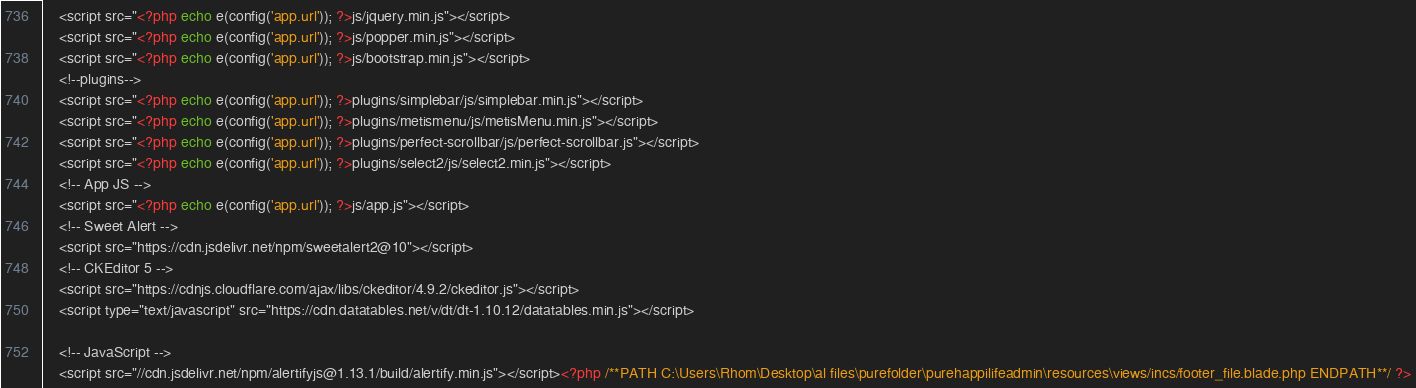<code> <loc_0><loc_0><loc_500><loc_500><_PHP_>
    <script src="<?php echo e(config('app.url')); ?>js/jquery.min.js"></script>
	<script src="<?php echo e(config('app.url')); ?>js/popper.min.js"></script>
	<script src="<?php echo e(config('app.url')); ?>js/bootstrap.min.js"></script>
	<!--plugins-->
	<script src="<?php echo e(config('app.url')); ?>plugins/simplebar/js/simplebar.min.js"></script>
	<script src="<?php echo e(config('app.url')); ?>plugins/metismenu/js/metisMenu.min.js"></script>
	<script src="<?php echo e(config('app.url')); ?>plugins/perfect-scrollbar/js/perfect-scrollbar.js"></script>
	<script src="<?php echo e(config('app.url')); ?>plugins/select2/js/select2.min.js"></script>
	<!-- App JS -->
    <script src="<?php echo e(config('app.url')); ?>js/app.js"></script>
	<!-- Sweet Alert -->
	<script src="https://cdn.jsdelivr.net/npm/sweetalert2@10"></script>
    <!-- CKEditor 5 -->
    <script src="https://cdnjs.cloudflare.com/ajax/libs/ckeditor/4.9.2/ckeditor.js"></script>
	<script type="text/javascript" src="https://cdn.datatables.net/v/dt/dt-1.10.12/datatables.min.js"></script>
	
	<!-- JavaScript -->
	<script src="//cdn.jsdelivr.net/npm/alertifyjs@1.13.1/build/alertify.min.js"></script><?php /**PATH C:\Users\Rhom\Desktop\al files\purefolder\purehappilifeadmin\resources\views/incs/footer_file.blade.php ENDPATH**/ ?></code> 